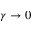<formula> <loc_0><loc_0><loc_500><loc_500>\gamma \to 0</formula> 